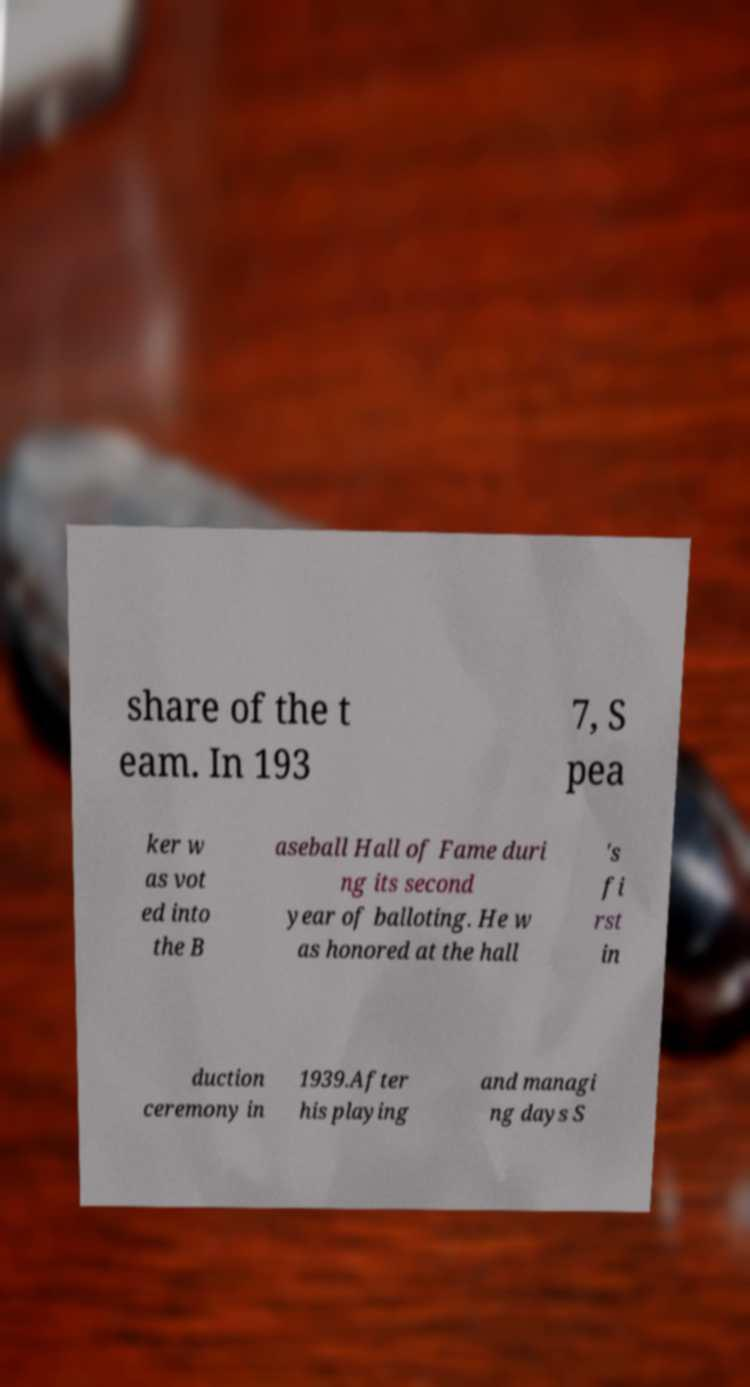Please read and relay the text visible in this image. What does it say? share of the t eam. In 193 7, S pea ker w as vot ed into the B aseball Hall of Fame duri ng its second year of balloting. He w as honored at the hall 's fi rst in duction ceremony in 1939.After his playing and managi ng days S 